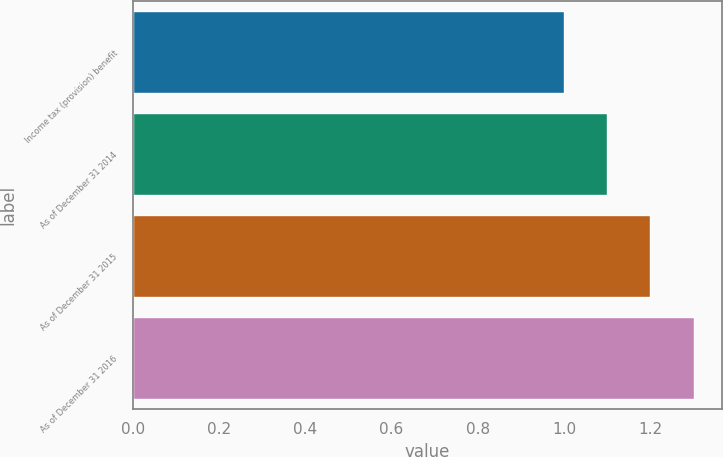Convert chart. <chart><loc_0><loc_0><loc_500><loc_500><bar_chart><fcel>Income tax (provision) benefit<fcel>As of December 31 2014<fcel>As of December 31 2015<fcel>As of December 31 2016<nl><fcel>1<fcel>1.1<fcel>1.2<fcel>1.3<nl></chart> 